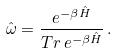Convert formula to latex. <formula><loc_0><loc_0><loc_500><loc_500>\hat { \omega } = \frac { e ^ { - \beta \hat { H } } } { T r \, e ^ { - \beta \hat { H } } } \, .</formula> 